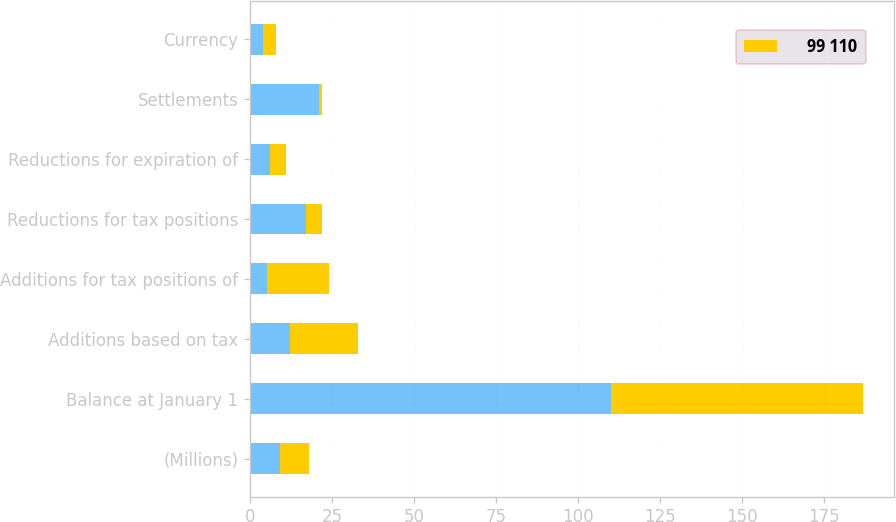<chart> <loc_0><loc_0><loc_500><loc_500><stacked_bar_chart><ecel><fcel>(Millions)<fcel>Balance at January 1<fcel>Additions based on tax<fcel>Additions for tax positions of<fcel>Reductions for tax positions<fcel>Reductions for expiration of<fcel>Settlements<fcel>Currency<nl><fcel>nan<fcel>9<fcel>110<fcel>12<fcel>5<fcel>17<fcel>6<fcel>21<fcel>4<nl><fcel>99 110<fcel>9<fcel>77<fcel>21<fcel>19<fcel>5<fcel>5<fcel>1<fcel>4<nl></chart> 